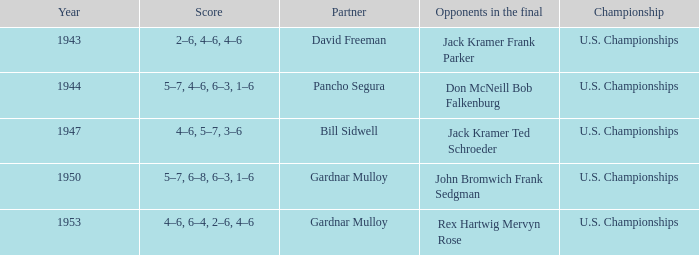Which Score has Opponents in the final of john bromwich frank sedgman? 5–7, 6–8, 6–3, 1–6. 